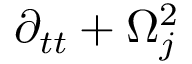Convert formula to latex. <formula><loc_0><loc_0><loc_500><loc_500>\partial _ { t t } + \Omega _ { j } ^ { 2 }</formula> 